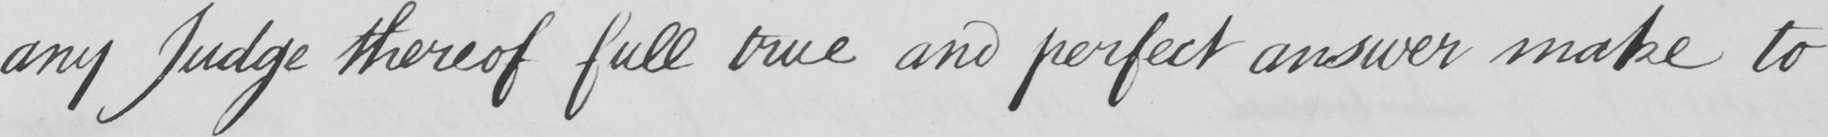Can you read and transcribe this handwriting? any Judge thereof full true and perfect answer make to 